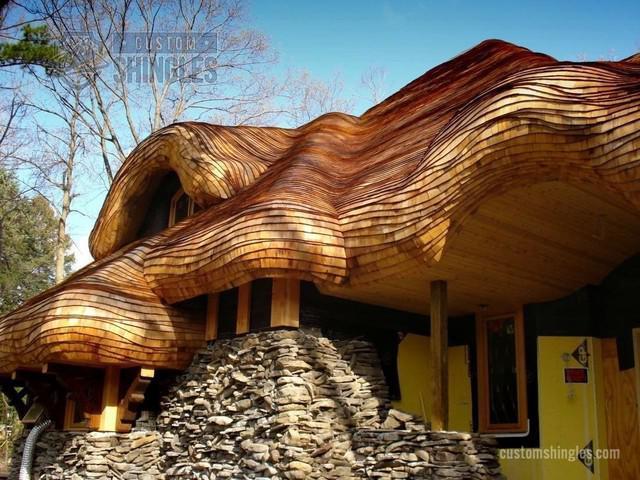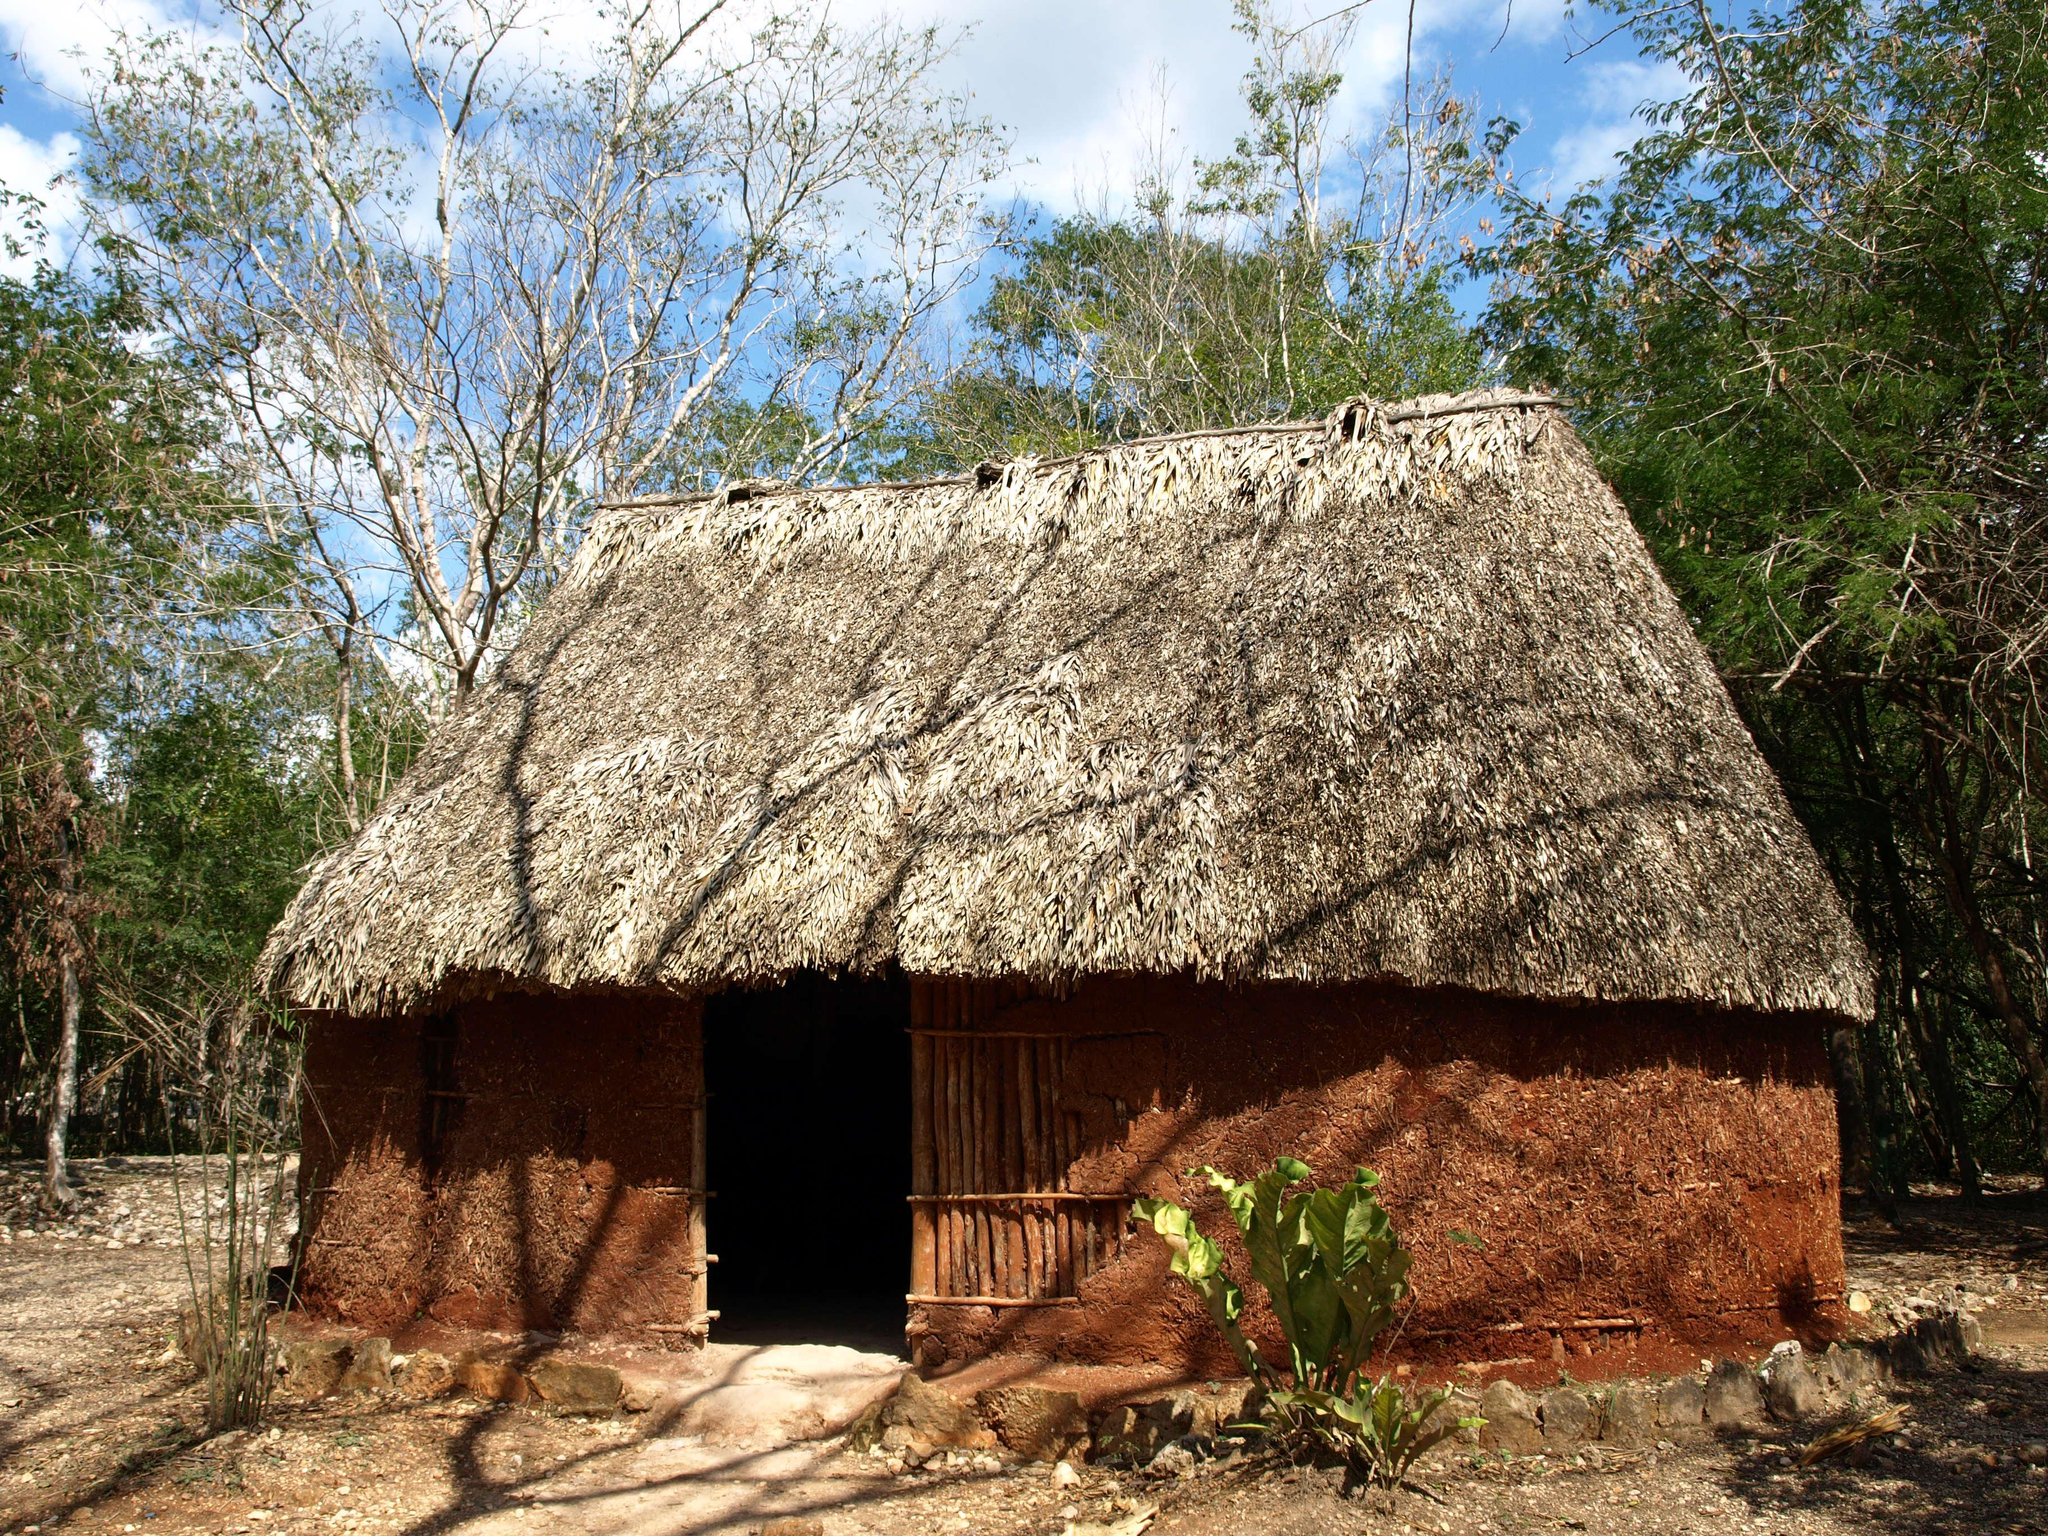The first image is the image on the left, the second image is the image on the right. Assess this claim about the two images: "An image shows a chimney-less roof that curves around an upper window, creating a semicircle arch over it.". Correct or not? Answer yes or no. Yes. The first image is the image on the left, the second image is the image on the right. For the images shown, is this caption "In at least one image there is a a home with it's walls in red brick with at least three windows and one  chimney." true? Answer yes or no. No. 